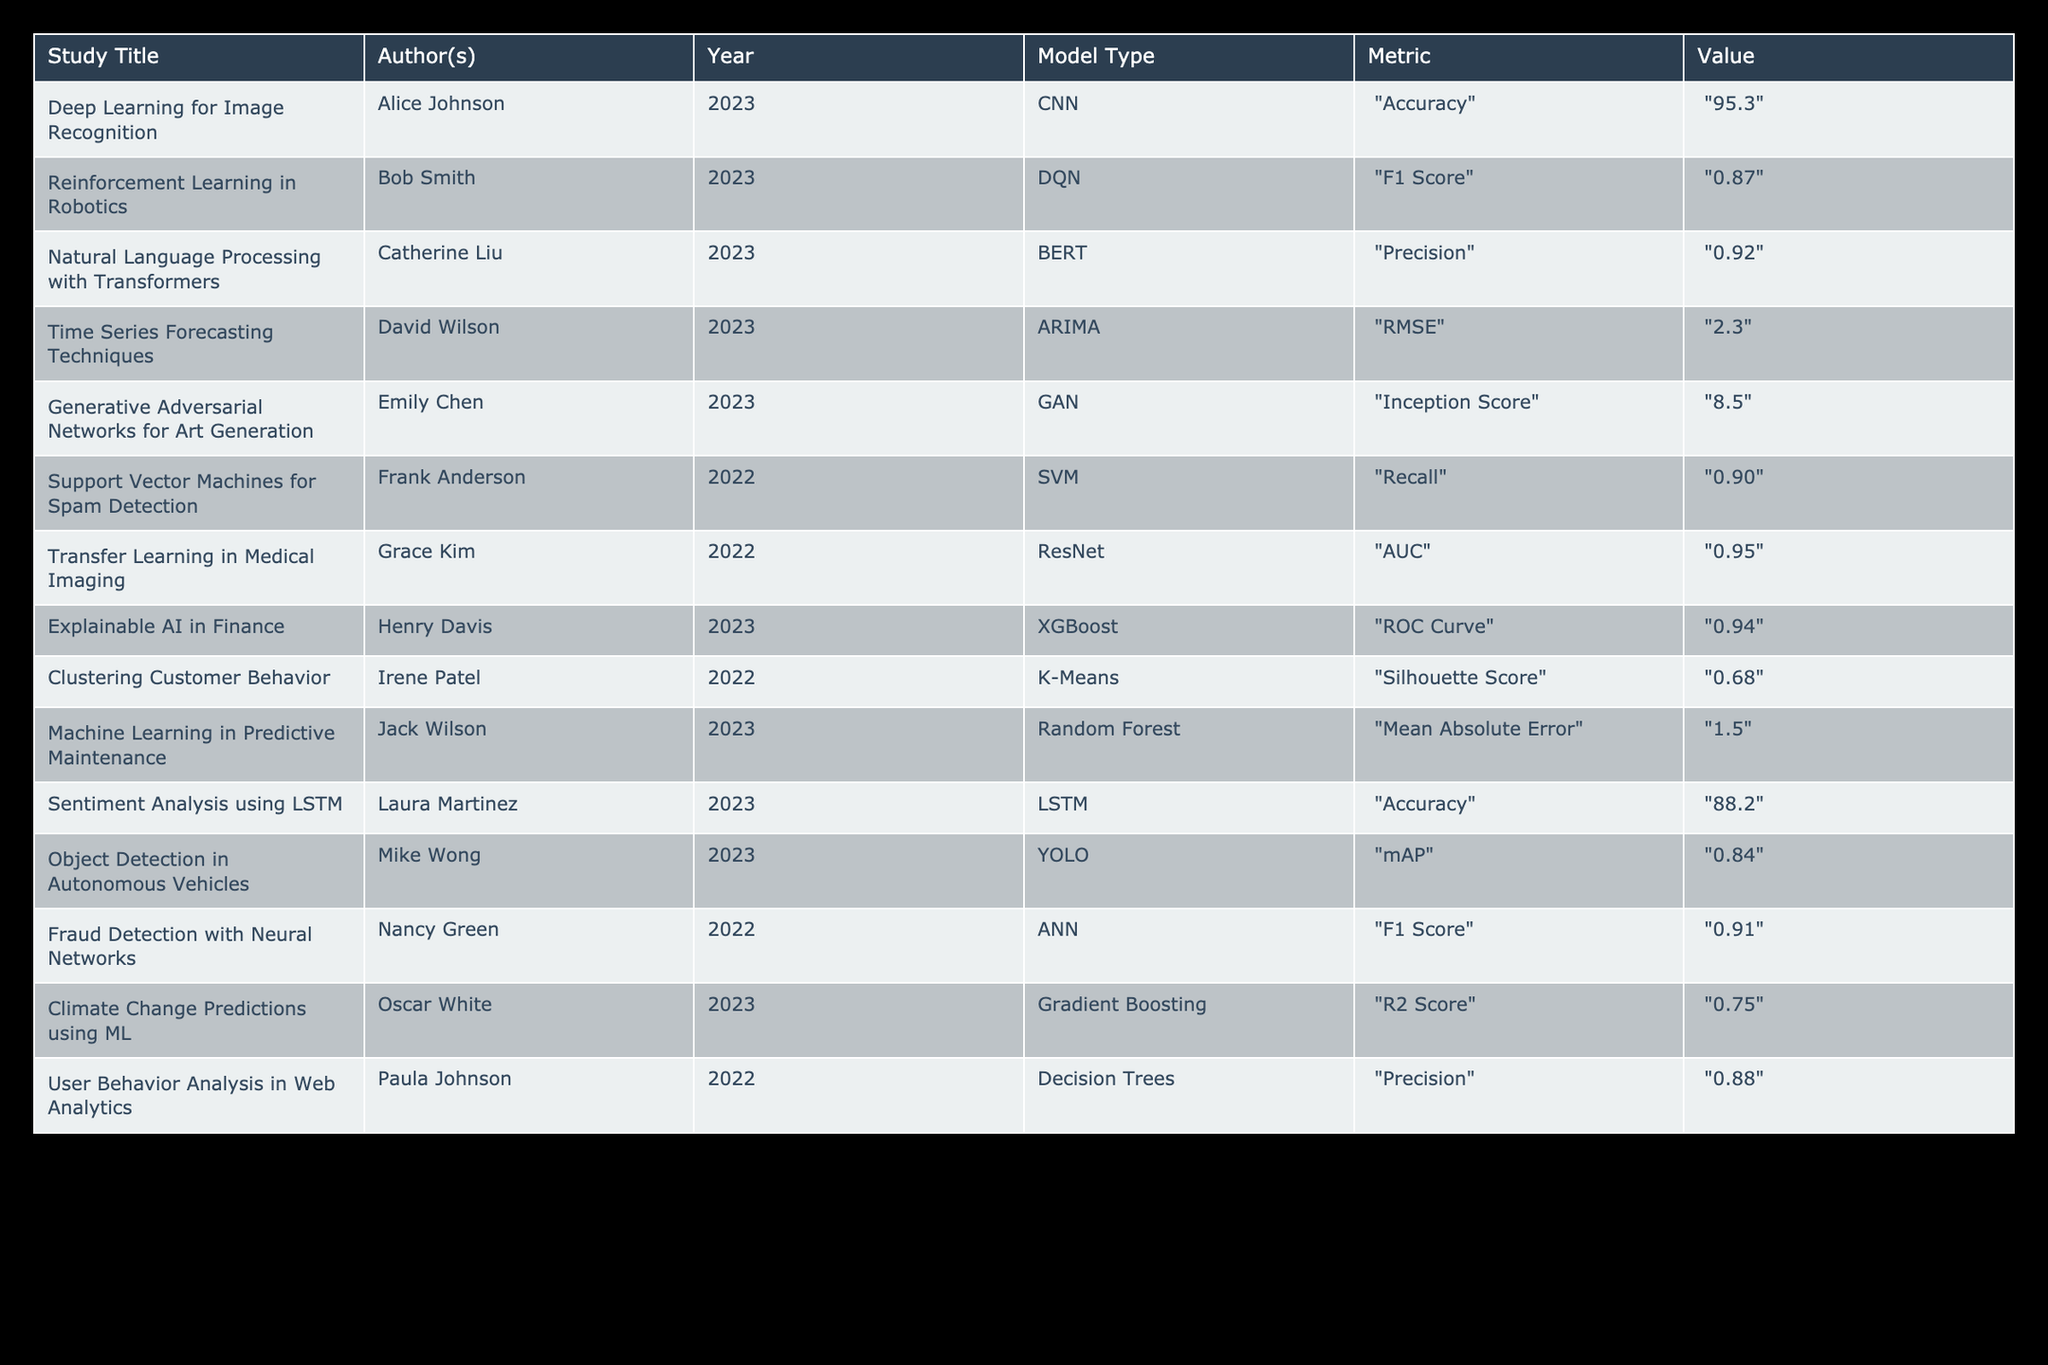What is the highest accuracy value in the table? The accuracy values are found in the "Accuracy" metric for the models. The "Deep Learning for Image Recognition" study by Alice Johnson shows an accuracy of 95.3, which is the highest. Other accuracy values are 88.2 from "Sentiment Analysis using LSTM." Therefore, 95.3 is the highest accuracy value.
Answer: 95.3 Which model type has the lowest RMSE value? The only model with the RMSE metric is "Time Series Forecasting Techniques" by David Wilson, which has an RMSE value of 2.3. Since it is the only listed RMSE value, it is also the lowest.
Answer: ARIMA Is the F1 Score for "Reinforcement Learning in Robotics" higher than that for "Fraud Detection with Neural Networks"? The F1 Score for "Reinforcement Learning in Robotics" is 0.87, and for "Fraud Detection with Neural Networks," it is 0.91. Since 0.87 is less than 0.91, the F1 Score for the former is not higher.
Answer: No What is the average precision value across the models? The models that report precision values are "Natural Language Processing with Transformers" at 0.92 and "User Behavior Analysis in Web Analytics" at 0.88. The average is calculated as (0.92 + 0.88) / 2 = 0.90.
Answer: 0.90 Is there a model with a recall value higher than 0.90? The SVM model from "Support Vector Machines for Spam Detection" has a recall value of 0.90. There are no values listed that are above 0.90. Thus, there is no model with a higher recall.
Answer: No Which study has the highest ROC Curve value? The "Explainable AI in Finance" study reports a ROC Curve value of 0.94, which is the highest among the listed studies. Other studies either did not report ROC Curve values or have lower metrics.
Answer: Explainable AI in Finance What is the difference between the maximum and minimum values of the Inception Score? The Inception Score of "Generative Adversarial Networks for Art Generation" is 8.5, and since this is the only reported value, it is both the maximum and minimum. Therefore, the difference is 8.5 - 8.5 = 0.
Answer: 0 Which metric was used for the model "Transfer Learning in Medical Imaging"? The study "Transfer Learning in Medical Imaging" used the AUC metric, which is explicitly stated in the table under the corresponding study.
Answer: AUC How many studies report an accuracy value greater than 90%? The studies with accuracy values greater than 90% are "Deep Learning for Image Recognition" with 95.3 and "Sentiment Analysis using LSTM" with 88.2. Only the first study qualifies, so just one study exceeds 90%.
Answer: 1 